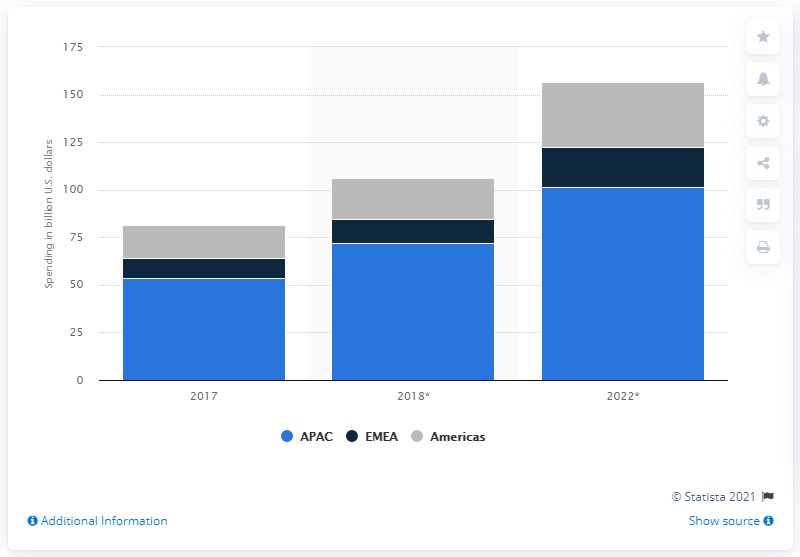Give some essential details in this illustration. In 2017, the amount of consumer spending on mobile apps in the Americas was approximately $17.5 billion. In 2022, the amount that consumers in the Americas will spend on mobile apps is predicted to be 34.1. 